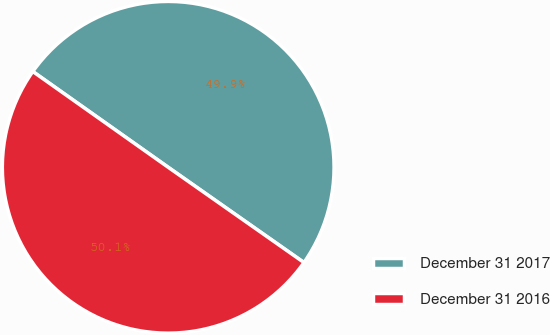Convert chart. <chart><loc_0><loc_0><loc_500><loc_500><pie_chart><fcel>December 31 2017<fcel>December 31 2016<nl><fcel>49.94%<fcel>50.06%<nl></chart> 